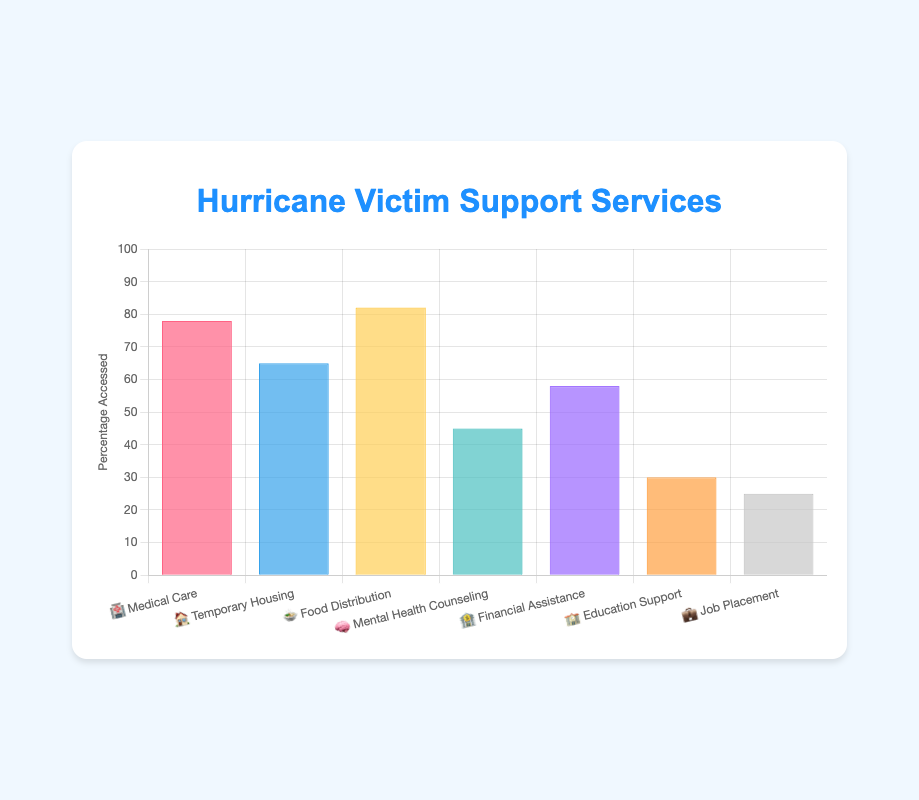What is the title of the chart? The title of the chart is written at the top, which is clearly labeled "Hurricane Victim Support Services."
Answer: Hurricane Victim Support Services What percentage of victims accessed Food Distribution services? 🍲 We can directly read the percentage value for Food Distribution services from the chart, which is represented as a bar with the label "🍲 Food Distribution."
Answer: 82% Which support service has the lowest percentage accessed? By comparing the lengths of all the bars, the shortest one corresponds to the "💼 Job Placement" service, which has the lowest percentage.
Answer: Job Placement How does the percentage for Financial Assistance 🏦 compare to Temporary Housing 🏠? The bar for Financial Assistance shows a percentage of 58%, while the bar for Temporary Housing shows 65%. Therefore, Financial Assistance is 7% less than Temporary Housing.
Answer: Less by 7% Calculate the average percentage of all the support services accessed. Adding all percentages (78 + 65 + 82 + 45 + 58 + 30 + 25) gives 383. There are 7 services, so the average is 383 / 7, which is approximately 54.71%.
Answer: 54.71% What are the total percentages of victims accessing either Medical Care 🏥 or Mental Health Counseling 🧠 services? The percentage accessing Medical Care is 78%, and for Mental Health Counseling, it is 45%. Adding these together gives 78 + 45 = 123%.
Answer: 123% Which service has been accessed more: Education Support 🏫 or Job Placement 💼? By comparing the bar lengths, Education Support stands at 30% while Job Placement is at 25%. Education Support has been accessed more.
Answer: Education Support What is the difference in percentage between the most accessed service and the least accessed service? The most accessed service is Food Distribution at 82%, and the least accessed is Job Placement at 25%. So, the difference is 82 - 25 = 57%.
Answer: 57% If you combine the percentages for Food Distribution 🍲 and Temporary Housing 🏠, what is the combined total? The percentage for Food Distribution is 82%, and for Temporary Housing, it is 65%. Adding these gives 82 + 65 = 147%.
Answer: 147% How many support services have a percentage accessed above 50%? By examining the bars, the services above 50% are Medical Care (78%), Temporary Housing (65%), Food Distribution (82%), and Financial Assistance (58%), which totals to 4 services.
Answer: 4 